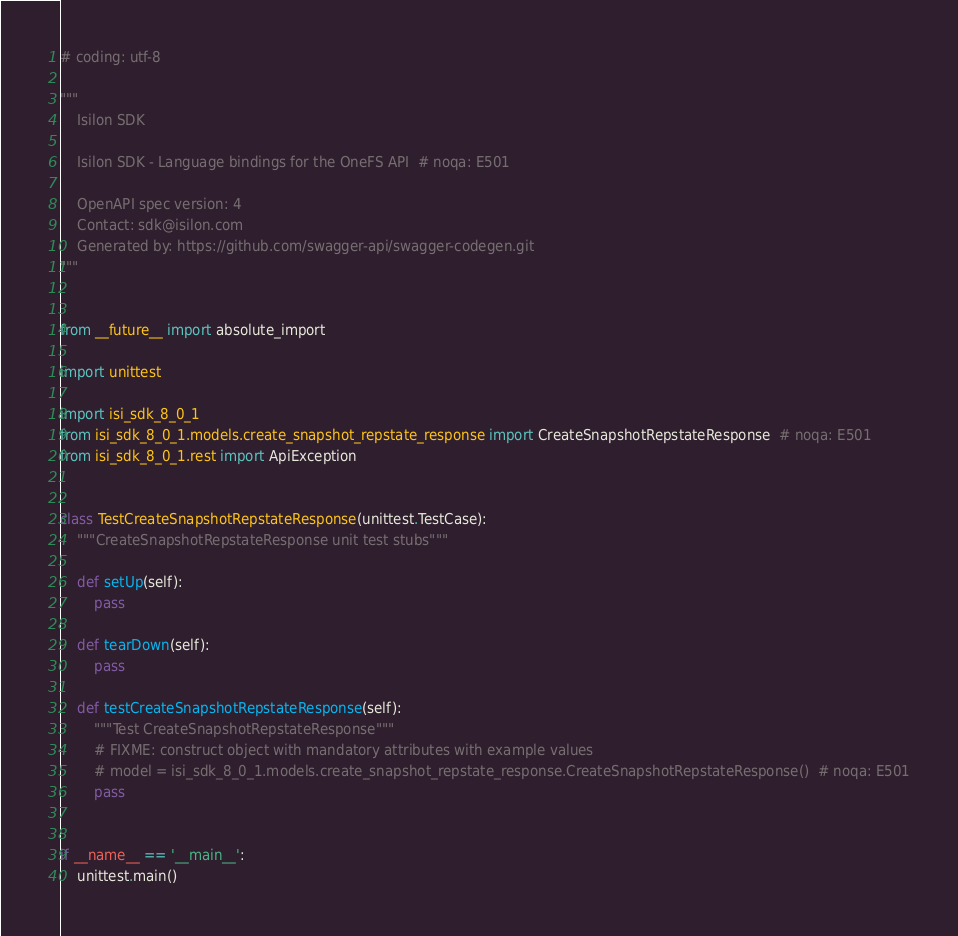Convert code to text. <code><loc_0><loc_0><loc_500><loc_500><_Python_># coding: utf-8

"""
    Isilon SDK

    Isilon SDK - Language bindings for the OneFS API  # noqa: E501

    OpenAPI spec version: 4
    Contact: sdk@isilon.com
    Generated by: https://github.com/swagger-api/swagger-codegen.git
"""


from __future__ import absolute_import

import unittest

import isi_sdk_8_0_1
from isi_sdk_8_0_1.models.create_snapshot_repstate_response import CreateSnapshotRepstateResponse  # noqa: E501
from isi_sdk_8_0_1.rest import ApiException


class TestCreateSnapshotRepstateResponse(unittest.TestCase):
    """CreateSnapshotRepstateResponse unit test stubs"""

    def setUp(self):
        pass

    def tearDown(self):
        pass

    def testCreateSnapshotRepstateResponse(self):
        """Test CreateSnapshotRepstateResponse"""
        # FIXME: construct object with mandatory attributes with example values
        # model = isi_sdk_8_0_1.models.create_snapshot_repstate_response.CreateSnapshotRepstateResponse()  # noqa: E501
        pass


if __name__ == '__main__':
    unittest.main()
</code> 